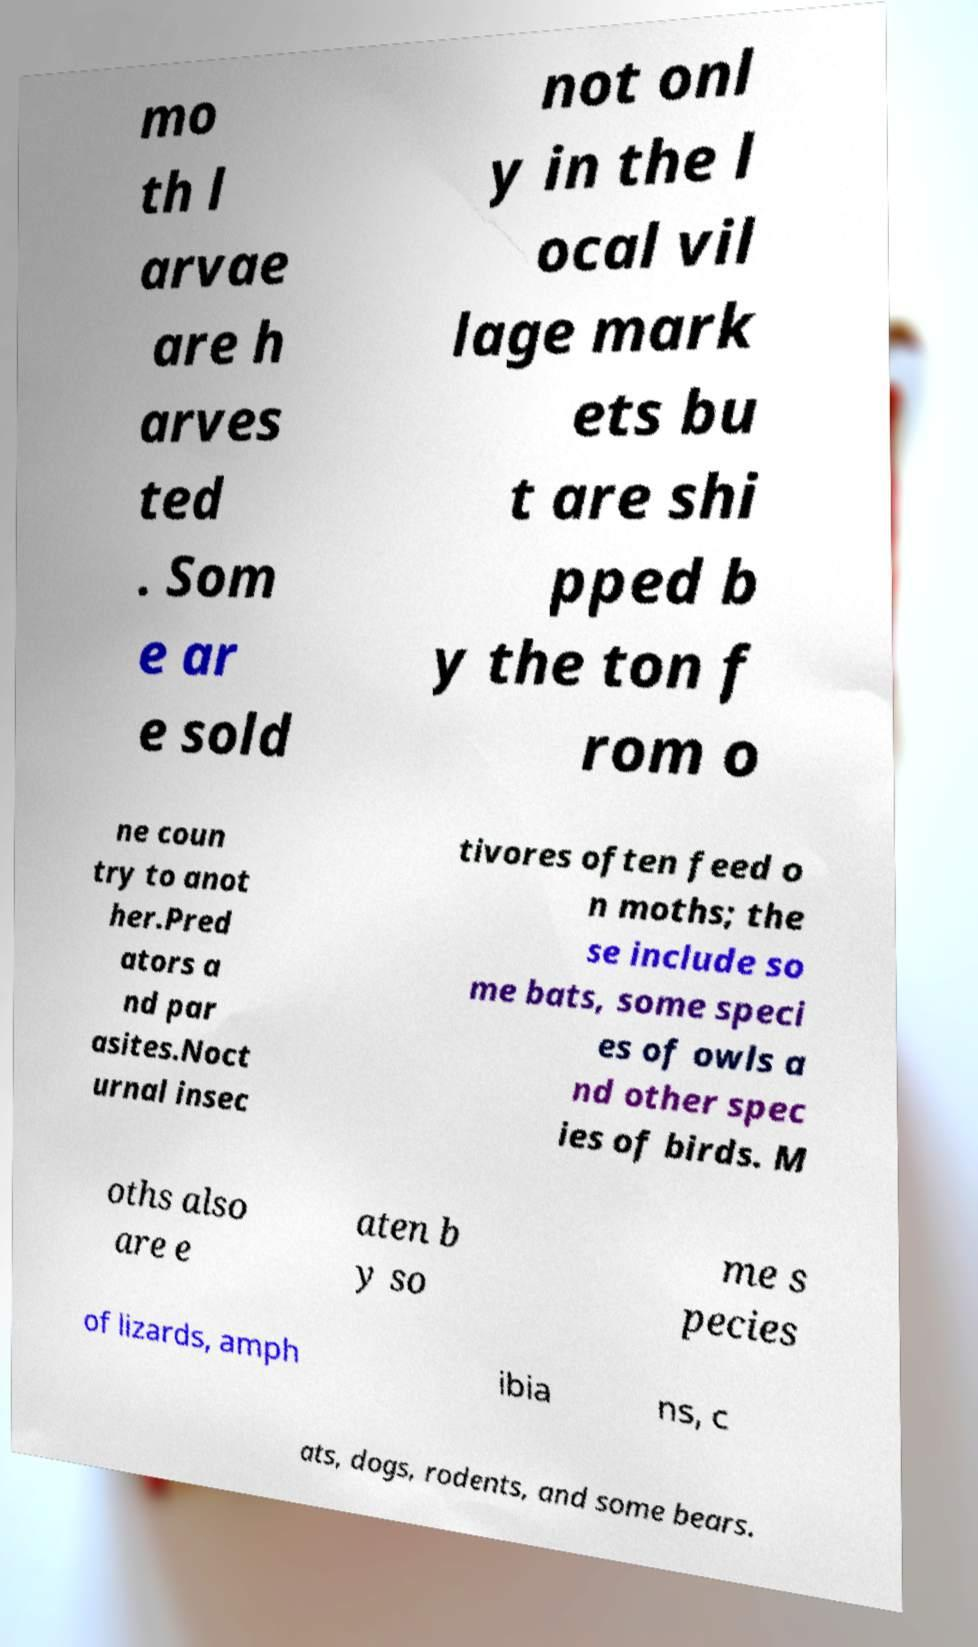Can you accurately transcribe the text from the provided image for me? mo th l arvae are h arves ted . Som e ar e sold not onl y in the l ocal vil lage mark ets bu t are shi pped b y the ton f rom o ne coun try to anot her.Pred ators a nd par asites.Noct urnal insec tivores often feed o n moths; the se include so me bats, some speci es of owls a nd other spec ies of birds. M oths also are e aten b y so me s pecies of lizards, amph ibia ns, c ats, dogs, rodents, and some bears. 